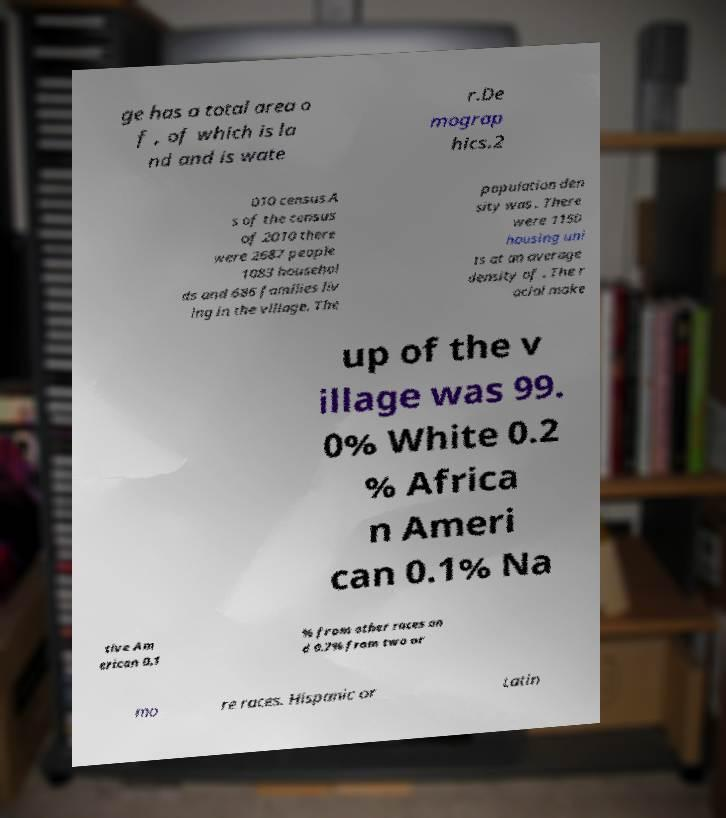Please identify and transcribe the text found in this image. ge has a total area o f , of which is la nd and is wate r.De mograp hics.2 010 census.A s of the census of 2010 there were 2687 people 1083 househol ds and 686 families liv ing in the village. The population den sity was . There were 1150 housing uni ts at an average density of . The r acial make up of the v illage was 99. 0% White 0.2 % Africa n Ameri can 0.1% Na tive Am erican 0.1 % from other races an d 0.7% from two or mo re races. Hispanic or Latin 